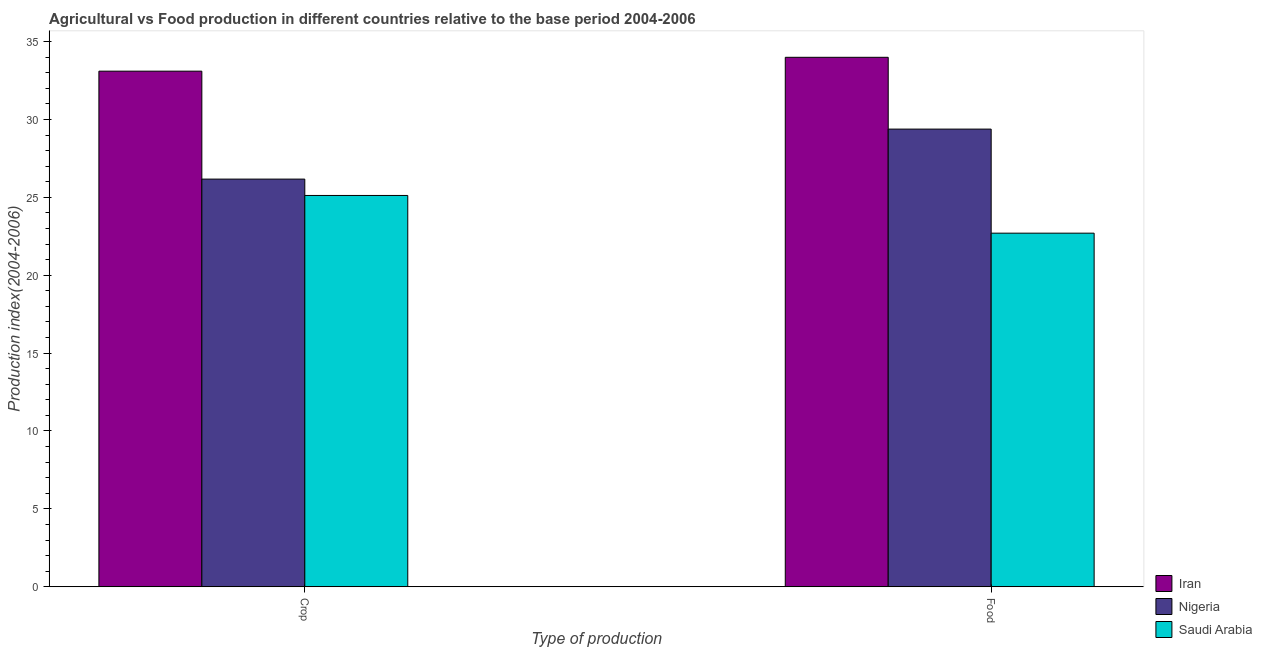How many different coloured bars are there?
Your answer should be very brief. 3. Are the number of bars per tick equal to the number of legend labels?
Your answer should be very brief. Yes. How many bars are there on the 1st tick from the right?
Offer a terse response. 3. What is the label of the 1st group of bars from the left?
Offer a very short reply. Crop. What is the food production index in Iran?
Your answer should be very brief. 33.99. Across all countries, what is the maximum food production index?
Offer a terse response. 33.99. Across all countries, what is the minimum crop production index?
Make the answer very short. 25.12. In which country was the crop production index maximum?
Provide a succinct answer. Iran. In which country was the food production index minimum?
Offer a terse response. Saudi Arabia. What is the total food production index in the graph?
Provide a succinct answer. 86.07. What is the difference between the food production index in Saudi Arabia and that in Iran?
Make the answer very short. -11.29. What is the difference between the food production index in Iran and the crop production index in Saudi Arabia?
Make the answer very short. 8.87. What is the average crop production index per country?
Your response must be concise. 28.13. What is the difference between the crop production index and food production index in Nigeria?
Provide a succinct answer. -3.21. What is the ratio of the food production index in Iran to that in Nigeria?
Your answer should be very brief. 1.16. What does the 1st bar from the left in Crop represents?
Offer a very short reply. Iran. What does the 3rd bar from the right in Food represents?
Your answer should be compact. Iran. How many bars are there?
Make the answer very short. 6. Does the graph contain grids?
Keep it short and to the point. No. How many legend labels are there?
Provide a short and direct response. 3. How are the legend labels stacked?
Your answer should be very brief. Vertical. What is the title of the graph?
Ensure brevity in your answer.  Agricultural vs Food production in different countries relative to the base period 2004-2006. Does "Algeria" appear as one of the legend labels in the graph?
Offer a terse response. No. What is the label or title of the X-axis?
Provide a short and direct response. Type of production. What is the label or title of the Y-axis?
Your answer should be compact. Production index(2004-2006). What is the Production index(2004-2006) in Iran in Crop?
Provide a succinct answer. 33.1. What is the Production index(2004-2006) of Nigeria in Crop?
Your response must be concise. 26.17. What is the Production index(2004-2006) of Saudi Arabia in Crop?
Ensure brevity in your answer.  25.12. What is the Production index(2004-2006) in Iran in Food?
Your response must be concise. 33.99. What is the Production index(2004-2006) of Nigeria in Food?
Your answer should be compact. 29.38. What is the Production index(2004-2006) of Saudi Arabia in Food?
Ensure brevity in your answer.  22.7. Across all Type of production, what is the maximum Production index(2004-2006) of Iran?
Give a very brief answer. 33.99. Across all Type of production, what is the maximum Production index(2004-2006) of Nigeria?
Ensure brevity in your answer.  29.38. Across all Type of production, what is the maximum Production index(2004-2006) in Saudi Arabia?
Your answer should be very brief. 25.12. Across all Type of production, what is the minimum Production index(2004-2006) in Iran?
Provide a short and direct response. 33.1. Across all Type of production, what is the minimum Production index(2004-2006) of Nigeria?
Your answer should be compact. 26.17. Across all Type of production, what is the minimum Production index(2004-2006) of Saudi Arabia?
Offer a terse response. 22.7. What is the total Production index(2004-2006) in Iran in the graph?
Your response must be concise. 67.09. What is the total Production index(2004-2006) in Nigeria in the graph?
Provide a short and direct response. 55.55. What is the total Production index(2004-2006) of Saudi Arabia in the graph?
Provide a succinct answer. 47.82. What is the difference between the Production index(2004-2006) in Iran in Crop and that in Food?
Provide a succinct answer. -0.89. What is the difference between the Production index(2004-2006) of Nigeria in Crop and that in Food?
Offer a terse response. -3.21. What is the difference between the Production index(2004-2006) of Saudi Arabia in Crop and that in Food?
Ensure brevity in your answer.  2.42. What is the difference between the Production index(2004-2006) in Iran in Crop and the Production index(2004-2006) in Nigeria in Food?
Give a very brief answer. 3.72. What is the difference between the Production index(2004-2006) of Nigeria in Crop and the Production index(2004-2006) of Saudi Arabia in Food?
Make the answer very short. 3.47. What is the average Production index(2004-2006) of Iran per Type of production?
Your answer should be compact. 33.55. What is the average Production index(2004-2006) in Nigeria per Type of production?
Ensure brevity in your answer.  27.77. What is the average Production index(2004-2006) of Saudi Arabia per Type of production?
Make the answer very short. 23.91. What is the difference between the Production index(2004-2006) of Iran and Production index(2004-2006) of Nigeria in Crop?
Your answer should be compact. 6.93. What is the difference between the Production index(2004-2006) of Iran and Production index(2004-2006) of Saudi Arabia in Crop?
Offer a terse response. 7.98. What is the difference between the Production index(2004-2006) in Iran and Production index(2004-2006) in Nigeria in Food?
Your answer should be compact. 4.61. What is the difference between the Production index(2004-2006) in Iran and Production index(2004-2006) in Saudi Arabia in Food?
Keep it short and to the point. 11.29. What is the difference between the Production index(2004-2006) in Nigeria and Production index(2004-2006) in Saudi Arabia in Food?
Offer a very short reply. 6.68. What is the ratio of the Production index(2004-2006) of Iran in Crop to that in Food?
Make the answer very short. 0.97. What is the ratio of the Production index(2004-2006) of Nigeria in Crop to that in Food?
Your response must be concise. 0.89. What is the ratio of the Production index(2004-2006) in Saudi Arabia in Crop to that in Food?
Offer a very short reply. 1.11. What is the difference between the highest and the second highest Production index(2004-2006) in Iran?
Offer a terse response. 0.89. What is the difference between the highest and the second highest Production index(2004-2006) of Nigeria?
Offer a terse response. 3.21. What is the difference between the highest and the second highest Production index(2004-2006) in Saudi Arabia?
Offer a terse response. 2.42. What is the difference between the highest and the lowest Production index(2004-2006) in Iran?
Keep it short and to the point. 0.89. What is the difference between the highest and the lowest Production index(2004-2006) of Nigeria?
Your answer should be very brief. 3.21. What is the difference between the highest and the lowest Production index(2004-2006) in Saudi Arabia?
Offer a very short reply. 2.42. 